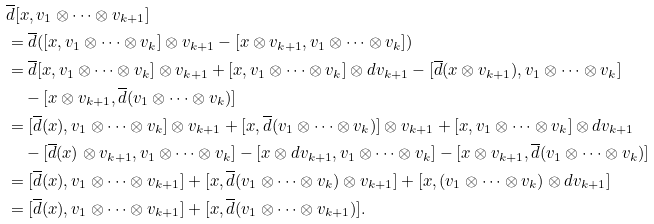Convert formula to latex. <formula><loc_0><loc_0><loc_500><loc_500>& \overline { d } [ x , v _ { 1 } \otimes \cdots \otimes v _ { k + 1 } ] \\ & = \overline { d } ( [ x , v _ { 1 } \otimes \cdots \otimes v _ { k } ] \otimes v _ { k + 1 } - [ x \otimes v _ { k + 1 } , v _ { 1 } \otimes \cdots \otimes v _ { k } ] ) \\ & = \overline { d } [ x , v _ { 1 } \otimes \cdots \otimes v _ { k } ] \otimes v _ { k + 1 } + [ x , v _ { 1 } \otimes \cdots \otimes v _ { k } ] \otimes d v _ { k + 1 } - [ \overline { d } ( x \otimes v _ { k + 1 } ) , v _ { 1 } \otimes \cdots \otimes v _ { k } ] \\ & \quad - [ x \otimes v _ { k + 1 } , \overline { d } ( v _ { 1 } \otimes \cdots \otimes v _ { k } ) ] \\ & = [ \overline { d } ( x ) , v _ { 1 } \otimes \cdots \otimes v _ { k } ] \otimes v _ { k + 1 } + [ x , \overline { d } ( v _ { 1 } \otimes \cdots \otimes v _ { k } ) ] \otimes v _ { k + 1 } + [ x , v _ { 1 } \otimes \cdots \otimes v _ { k } ] \otimes d v _ { k + 1 } \\ & \quad - [ \overline { d } ( x ) \otimes v _ { k + 1 } , v _ { 1 } \otimes \cdots \otimes v _ { k } ] - [ x \otimes d v _ { k + 1 } , v _ { 1 } \otimes \cdots \otimes v _ { k } ] - [ x \otimes v _ { k + 1 } , \overline { d } ( v _ { 1 } \otimes \cdots \otimes v _ { k } ) ] \\ & = [ \overline { d } ( x ) , v _ { 1 } \otimes \cdots \otimes v _ { k + 1 } ] + [ x , \overline { d } ( v _ { 1 } \otimes \cdots \otimes v _ { k } ) \otimes v _ { k + 1 } ] + [ x , ( v _ { 1 } \otimes \cdots \otimes v _ { k } ) \otimes d v _ { k + 1 } ] \\ & = [ \overline { d } ( x ) , v _ { 1 } \otimes \cdots \otimes v _ { k + 1 } ] + [ x , \overline { d } ( v _ { 1 } \otimes \cdots \otimes v _ { k + 1 } ) ] .</formula> 